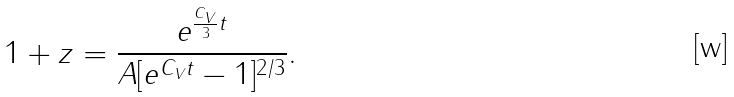Convert formula to latex. <formula><loc_0><loc_0><loc_500><loc_500>1 + z = \frac { e ^ { \frac { C _ { V } } { 3 } t } } { A [ e ^ { C _ { V } t } - 1 ] ^ { 2 / 3 } } .</formula> 